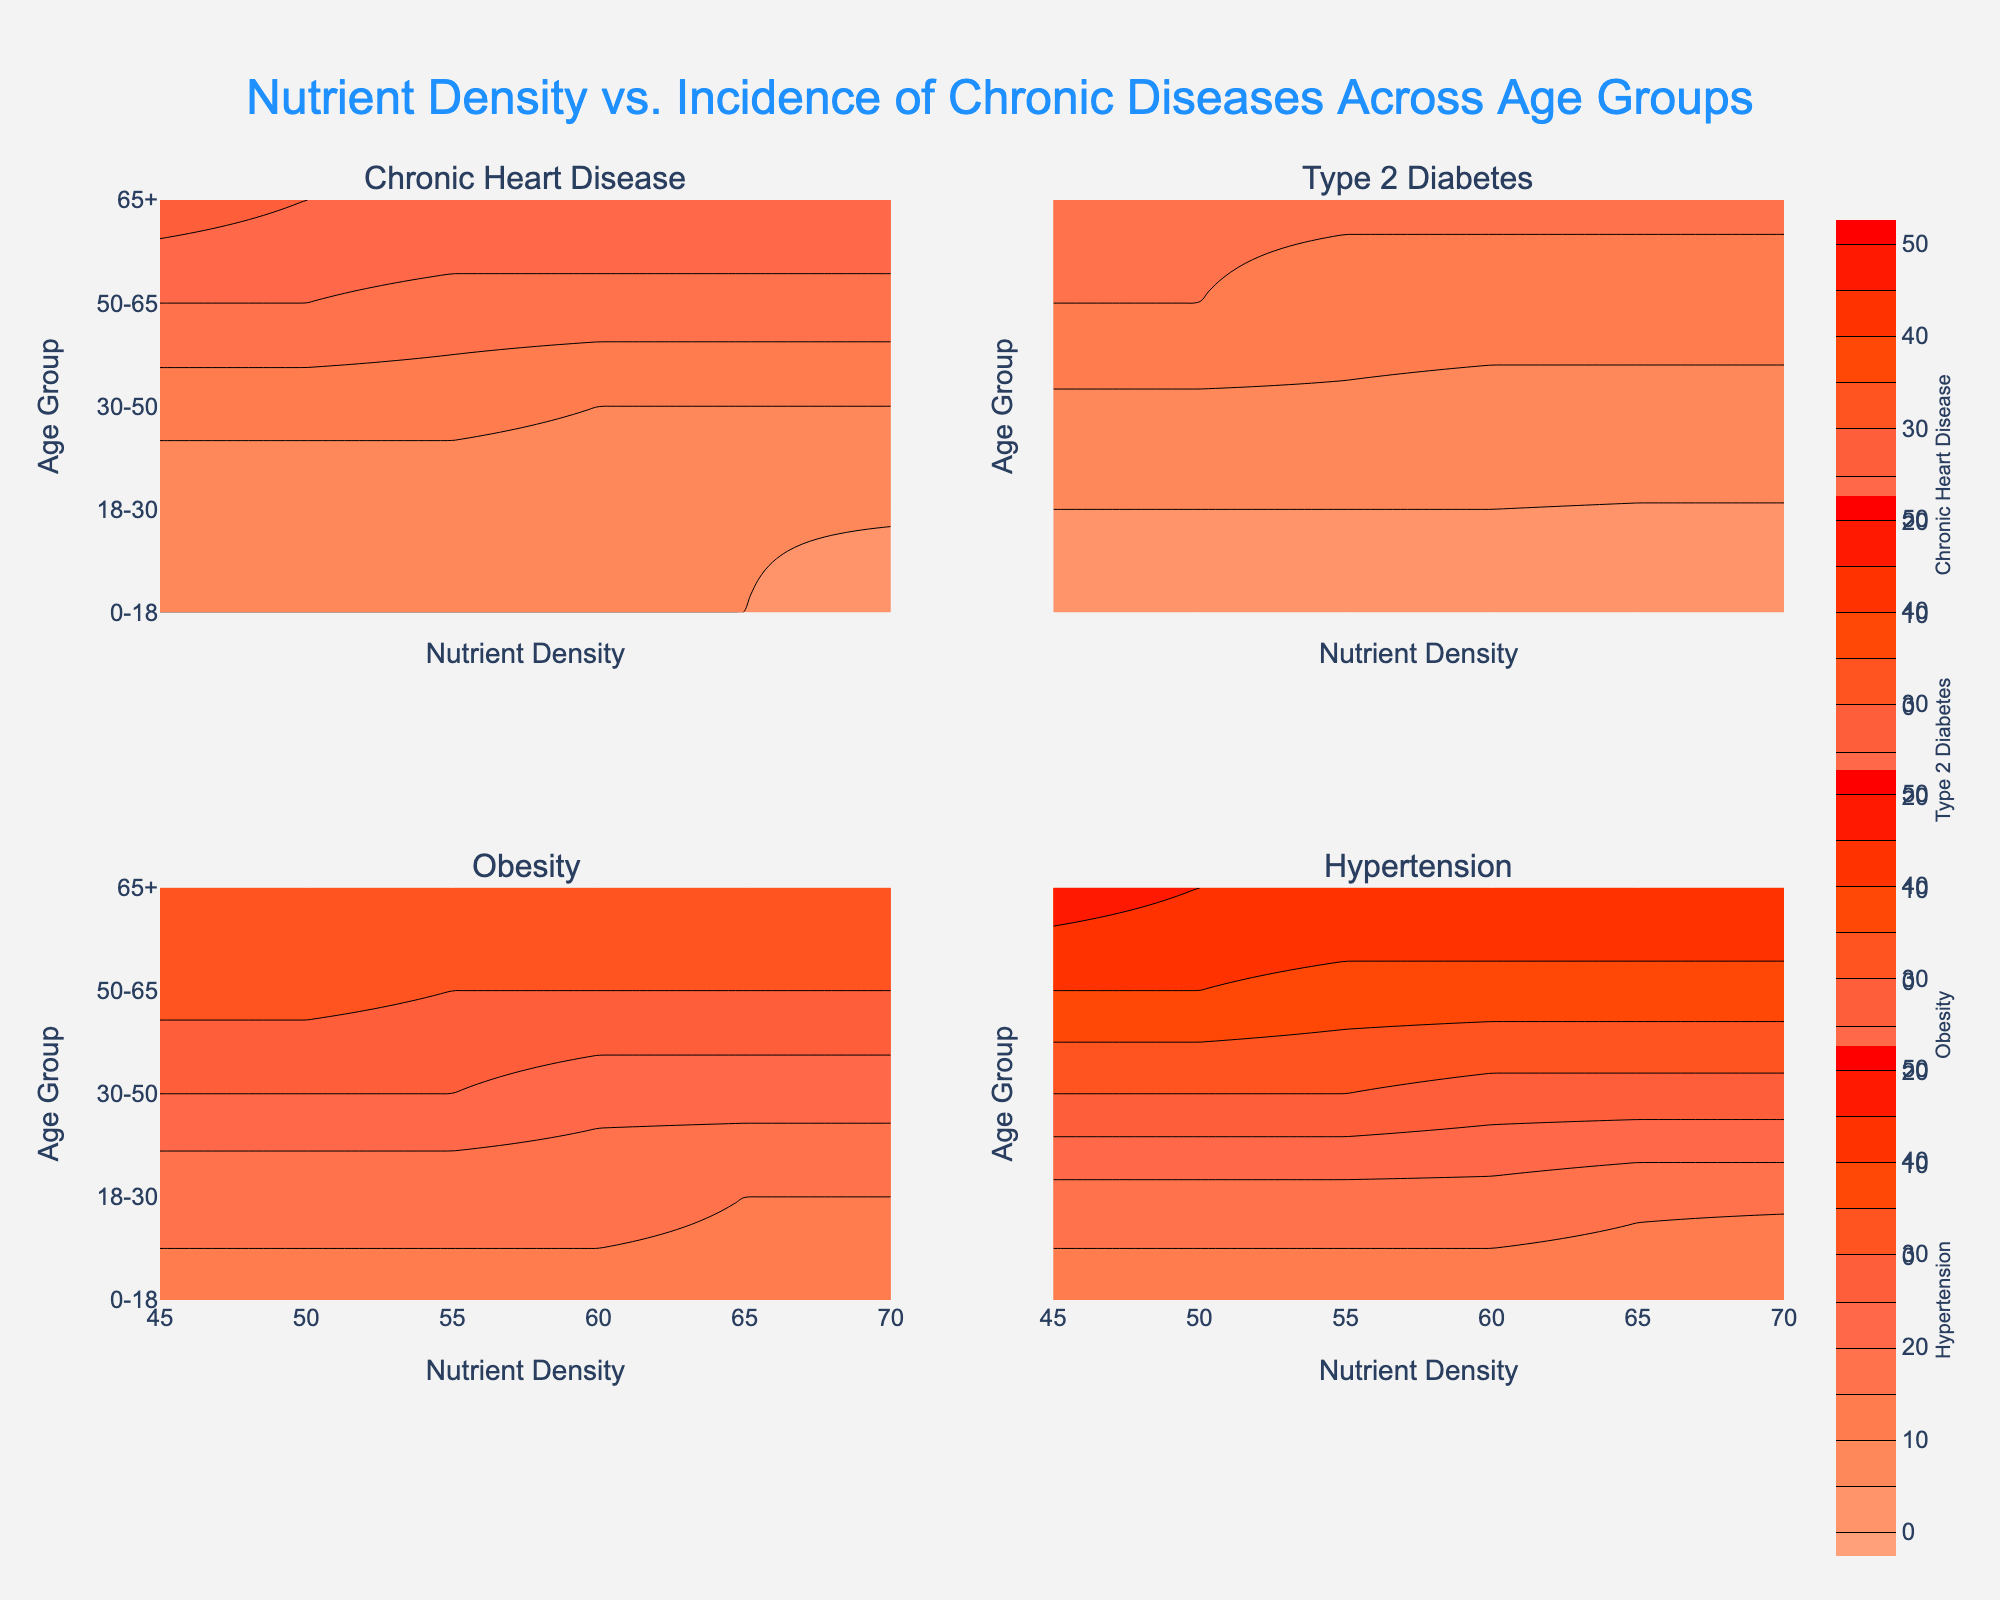What is the title of the figure? The title is displayed at the top of the figure, central, and in a blue color. It reads "Nutrient Density vs. Incidence of Chronic Diseases Across Age Groups."
Answer: Nutrient Density vs. Incidence of Chronic Diseases Across Age Groups Which chronic disease shows the highest incidence in the 65+ age group? Look at the contour plots for the 65+ age group and identify the highest value across each disease: Chronic Heart Disease, Type 2 Diabetes, Obesity, and Hypertension. Hypertension shows the highest incidences.
Answer: Hypertension In the age group 18-30, which chronic disease has the lowest incidence when nutrient density is at 60? In the subplot for the 18-30 age group, find the contour lines at nutrient density = 60. Compare the values of Chronic Heart Disease, Type 2 Diabetes, Obesity, and Hypertension.
Answer: Type 2 Diabetes How does the incidence of Chronic Heart Disease change with decreasing nutrient density for the 30-50 age group? Look for the contour plot specific to Chronic Heart Disease. Trace the change in the contour lines for the 30-50 age group as nutrient density decreases from 70 to 45.
Answer: It increases Which age group shows the least variance in incidence of Type 2 Diabetes across nutrient densities? Compare the spread of incidence values for Type 2 Diabetes across the different age groups. The group with the smallest range or change in this subplot indicates the least variance.
Answer: 0-18 For the 50-65 age group, how does the incidence of Obesity change as nutrient density increases from 50 to 60? In the subplot for Obesity, trace the contour lines for the 50-65 age group as nutrient density increases from 50 to 60. Note the values and see the change.
Answer: It decreases What can be observed about the incidence of Hypertension in the 0-18 age group as nutrient density increases? In the Hypertension subplot, follow the contour lines for the 0-18 age group as nutrient density increases. Compare the values.
Answer: It decreases Compare the pattern of incidence rates for Obesity between the 30-50 and 65+ age groups. Look at the Obesity subplot and compare the contour lines for 30-50 and 65+ age groups across different nutrient densities. Analyze the trends and changes.
Answer: 65+ has higher incidence rates and a steeper increase What range of nutrient density values appears to be most effective in minimizing Chronic Heart Disease incidence across all age groups? Check the Chronic Heart Disease subplot for nutrient density ranges where the contour lines show the lowest incidence values, consistent across age groups.
Answer: 65-70 Which chronic disease shows the most pronounced decrease in incidence with increasing nutrient density across all age groups? Examine all subplots for trends in incidence decrease with increasing nutrient density. Identify which disease shows the largest decrease across age groups.
Answer: Hypertension 